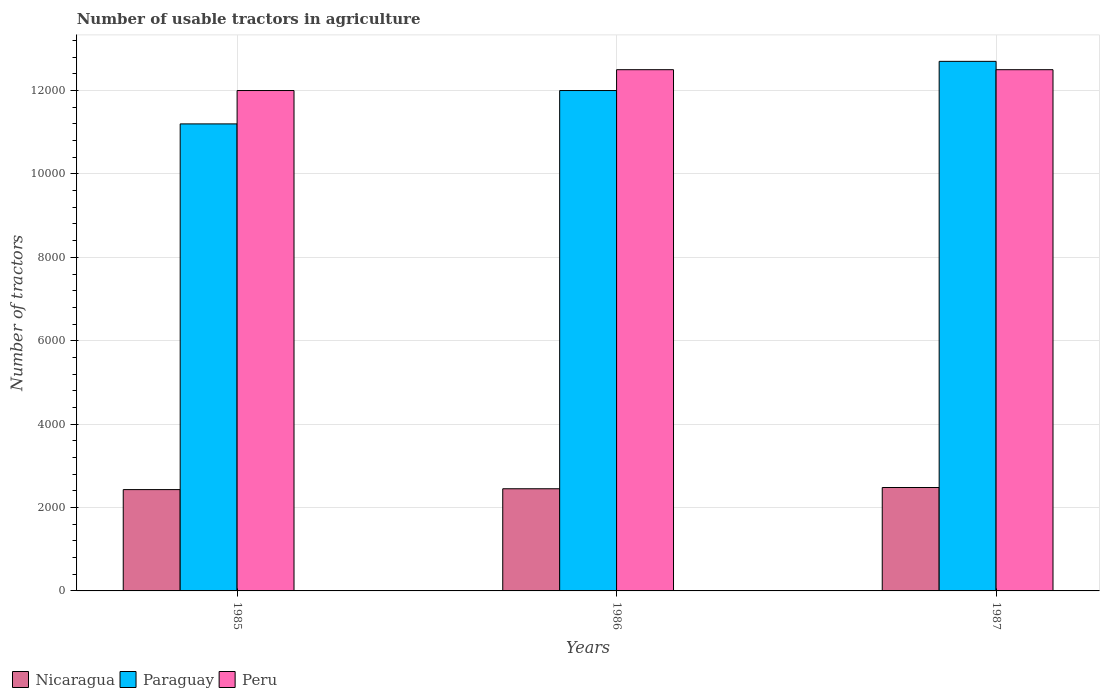How many different coloured bars are there?
Keep it short and to the point. 3. How many groups of bars are there?
Your answer should be very brief. 3. Are the number of bars per tick equal to the number of legend labels?
Your response must be concise. Yes. How many bars are there on the 1st tick from the right?
Your answer should be very brief. 3. What is the label of the 1st group of bars from the left?
Offer a very short reply. 1985. In how many cases, is the number of bars for a given year not equal to the number of legend labels?
Your response must be concise. 0. What is the number of usable tractors in agriculture in Nicaragua in 1987?
Offer a terse response. 2480. Across all years, what is the maximum number of usable tractors in agriculture in Peru?
Your response must be concise. 1.25e+04. Across all years, what is the minimum number of usable tractors in agriculture in Peru?
Your response must be concise. 1.20e+04. In which year was the number of usable tractors in agriculture in Paraguay minimum?
Your response must be concise. 1985. What is the total number of usable tractors in agriculture in Nicaragua in the graph?
Ensure brevity in your answer.  7360. What is the difference between the number of usable tractors in agriculture in Nicaragua in 1986 and that in 1987?
Provide a succinct answer. -30. What is the difference between the number of usable tractors in agriculture in Nicaragua in 1986 and the number of usable tractors in agriculture in Peru in 1985?
Offer a terse response. -9550. What is the average number of usable tractors in agriculture in Peru per year?
Give a very brief answer. 1.23e+04. In the year 1985, what is the difference between the number of usable tractors in agriculture in Paraguay and number of usable tractors in agriculture in Nicaragua?
Provide a short and direct response. 8770. Is the number of usable tractors in agriculture in Nicaragua in 1985 less than that in 1987?
Ensure brevity in your answer.  Yes. What is the difference between the highest and the second highest number of usable tractors in agriculture in Paraguay?
Provide a short and direct response. 700. In how many years, is the number of usable tractors in agriculture in Peru greater than the average number of usable tractors in agriculture in Peru taken over all years?
Your answer should be very brief. 2. What does the 1st bar from the left in 1985 represents?
Offer a terse response. Nicaragua. Is it the case that in every year, the sum of the number of usable tractors in agriculture in Paraguay and number of usable tractors in agriculture in Nicaragua is greater than the number of usable tractors in agriculture in Peru?
Your answer should be compact. Yes. Are all the bars in the graph horizontal?
Provide a succinct answer. No. How many years are there in the graph?
Make the answer very short. 3. What is the difference between two consecutive major ticks on the Y-axis?
Your response must be concise. 2000. Does the graph contain any zero values?
Keep it short and to the point. No. Does the graph contain grids?
Offer a terse response. Yes. How many legend labels are there?
Your answer should be compact. 3. How are the legend labels stacked?
Provide a succinct answer. Horizontal. What is the title of the graph?
Make the answer very short. Number of usable tractors in agriculture. What is the label or title of the Y-axis?
Your answer should be compact. Number of tractors. What is the Number of tractors of Nicaragua in 1985?
Ensure brevity in your answer.  2430. What is the Number of tractors in Paraguay in 1985?
Your response must be concise. 1.12e+04. What is the Number of tractors in Peru in 1985?
Provide a short and direct response. 1.20e+04. What is the Number of tractors in Nicaragua in 1986?
Your answer should be compact. 2450. What is the Number of tractors in Paraguay in 1986?
Your answer should be very brief. 1.20e+04. What is the Number of tractors in Peru in 1986?
Offer a terse response. 1.25e+04. What is the Number of tractors in Nicaragua in 1987?
Offer a very short reply. 2480. What is the Number of tractors in Paraguay in 1987?
Your response must be concise. 1.27e+04. What is the Number of tractors in Peru in 1987?
Offer a very short reply. 1.25e+04. Across all years, what is the maximum Number of tractors in Nicaragua?
Offer a terse response. 2480. Across all years, what is the maximum Number of tractors in Paraguay?
Offer a very short reply. 1.27e+04. Across all years, what is the maximum Number of tractors in Peru?
Offer a very short reply. 1.25e+04. Across all years, what is the minimum Number of tractors in Nicaragua?
Your response must be concise. 2430. Across all years, what is the minimum Number of tractors of Paraguay?
Offer a very short reply. 1.12e+04. Across all years, what is the minimum Number of tractors in Peru?
Your answer should be very brief. 1.20e+04. What is the total Number of tractors of Nicaragua in the graph?
Offer a very short reply. 7360. What is the total Number of tractors of Paraguay in the graph?
Your response must be concise. 3.59e+04. What is the total Number of tractors in Peru in the graph?
Give a very brief answer. 3.70e+04. What is the difference between the Number of tractors of Paraguay in 1985 and that in 1986?
Offer a terse response. -800. What is the difference between the Number of tractors in Peru in 1985 and that in 1986?
Offer a terse response. -500. What is the difference between the Number of tractors in Nicaragua in 1985 and that in 1987?
Offer a terse response. -50. What is the difference between the Number of tractors of Paraguay in 1985 and that in 1987?
Your answer should be very brief. -1500. What is the difference between the Number of tractors of Peru in 1985 and that in 1987?
Your answer should be very brief. -500. What is the difference between the Number of tractors of Nicaragua in 1986 and that in 1987?
Make the answer very short. -30. What is the difference between the Number of tractors of Paraguay in 1986 and that in 1987?
Your answer should be compact. -700. What is the difference between the Number of tractors in Nicaragua in 1985 and the Number of tractors in Paraguay in 1986?
Keep it short and to the point. -9570. What is the difference between the Number of tractors of Nicaragua in 1985 and the Number of tractors of Peru in 1986?
Your answer should be very brief. -1.01e+04. What is the difference between the Number of tractors in Paraguay in 1985 and the Number of tractors in Peru in 1986?
Give a very brief answer. -1300. What is the difference between the Number of tractors in Nicaragua in 1985 and the Number of tractors in Paraguay in 1987?
Give a very brief answer. -1.03e+04. What is the difference between the Number of tractors in Nicaragua in 1985 and the Number of tractors in Peru in 1987?
Your answer should be very brief. -1.01e+04. What is the difference between the Number of tractors in Paraguay in 1985 and the Number of tractors in Peru in 1987?
Your response must be concise. -1300. What is the difference between the Number of tractors of Nicaragua in 1986 and the Number of tractors of Paraguay in 1987?
Your answer should be very brief. -1.02e+04. What is the difference between the Number of tractors in Nicaragua in 1986 and the Number of tractors in Peru in 1987?
Make the answer very short. -1.00e+04. What is the difference between the Number of tractors in Paraguay in 1986 and the Number of tractors in Peru in 1987?
Provide a succinct answer. -500. What is the average Number of tractors of Nicaragua per year?
Provide a short and direct response. 2453.33. What is the average Number of tractors of Paraguay per year?
Your response must be concise. 1.20e+04. What is the average Number of tractors in Peru per year?
Offer a very short reply. 1.23e+04. In the year 1985, what is the difference between the Number of tractors in Nicaragua and Number of tractors in Paraguay?
Ensure brevity in your answer.  -8770. In the year 1985, what is the difference between the Number of tractors of Nicaragua and Number of tractors of Peru?
Offer a very short reply. -9570. In the year 1985, what is the difference between the Number of tractors in Paraguay and Number of tractors in Peru?
Keep it short and to the point. -800. In the year 1986, what is the difference between the Number of tractors in Nicaragua and Number of tractors in Paraguay?
Offer a very short reply. -9550. In the year 1986, what is the difference between the Number of tractors in Nicaragua and Number of tractors in Peru?
Keep it short and to the point. -1.00e+04. In the year 1986, what is the difference between the Number of tractors of Paraguay and Number of tractors of Peru?
Your answer should be very brief. -500. In the year 1987, what is the difference between the Number of tractors of Nicaragua and Number of tractors of Paraguay?
Keep it short and to the point. -1.02e+04. In the year 1987, what is the difference between the Number of tractors of Nicaragua and Number of tractors of Peru?
Offer a very short reply. -1.00e+04. What is the ratio of the Number of tractors of Paraguay in 1985 to that in 1986?
Provide a succinct answer. 0.93. What is the ratio of the Number of tractors of Nicaragua in 1985 to that in 1987?
Offer a terse response. 0.98. What is the ratio of the Number of tractors of Paraguay in 1985 to that in 1987?
Ensure brevity in your answer.  0.88. What is the ratio of the Number of tractors of Nicaragua in 1986 to that in 1987?
Your answer should be very brief. 0.99. What is the ratio of the Number of tractors of Paraguay in 1986 to that in 1987?
Your answer should be compact. 0.94. What is the difference between the highest and the second highest Number of tractors in Nicaragua?
Ensure brevity in your answer.  30. What is the difference between the highest and the second highest Number of tractors of Paraguay?
Offer a very short reply. 700. What is the difference between the highest and the second highest Number of tractors in Peru?
Your answer should be compact. 0. What is the difference between the highest and the lowest Number of tractors in Paraguay?
Offer a very short reply. 1500. 